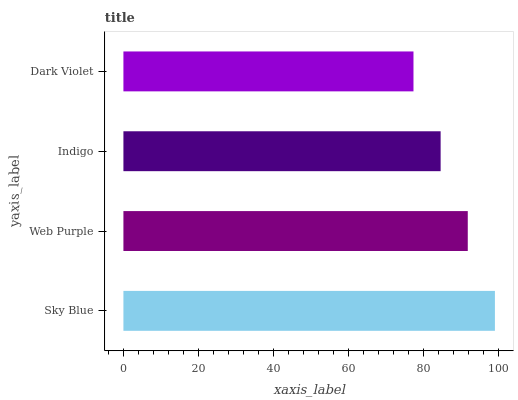Is Dark Violet the minimum?
Answer yes or no. Yes. Is Sky Blue the maximum?
Answer yes or no. Yes. Is Web Purple the minimum?
Answer yes or no. No. Is Web Purple the maximum?
Answer yes or no. No. Is Sky Blue greater than Web Purple?
Answer yes or no. Yes. Is Web Purple less than Sky Blue?
Answer yes or no. Yes. Is Web Purple greater than Sky Blue?
Answer yes or no. No. Is Sky Blue less than Web Purple?
Answer yes or no. No. Is Web Purple the high median?
Answer yes or no. Yes. Is Indigo the low median?
Answer yes or no. Yes. Is Indigo the high median?
Answer yes or no. No. Is Web Purple the low median?
Answer yes or no. No. 